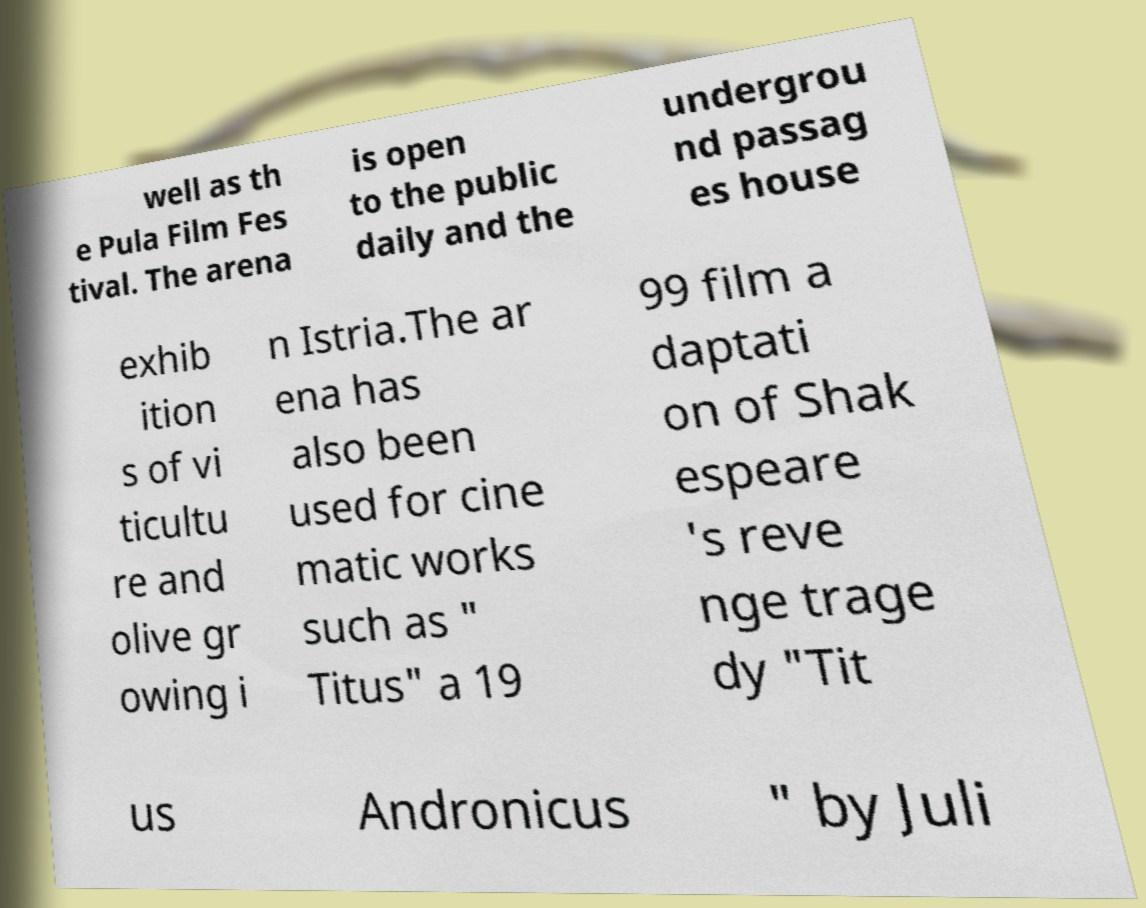Can you accurately transcribe the text from the provided image for me? well as th e Pula Film Fes tival. The arena is open to the public daily and the undergrou nd passag es house exhib ition s of vi ticultu re and olive gr owing i n Istria.The ar ena has also been used for cine matic works such as " Titus" a 19 99 film a daptati on of Shak espeare 's reve nge trage dy "Tit us Andronicus " by Juli 